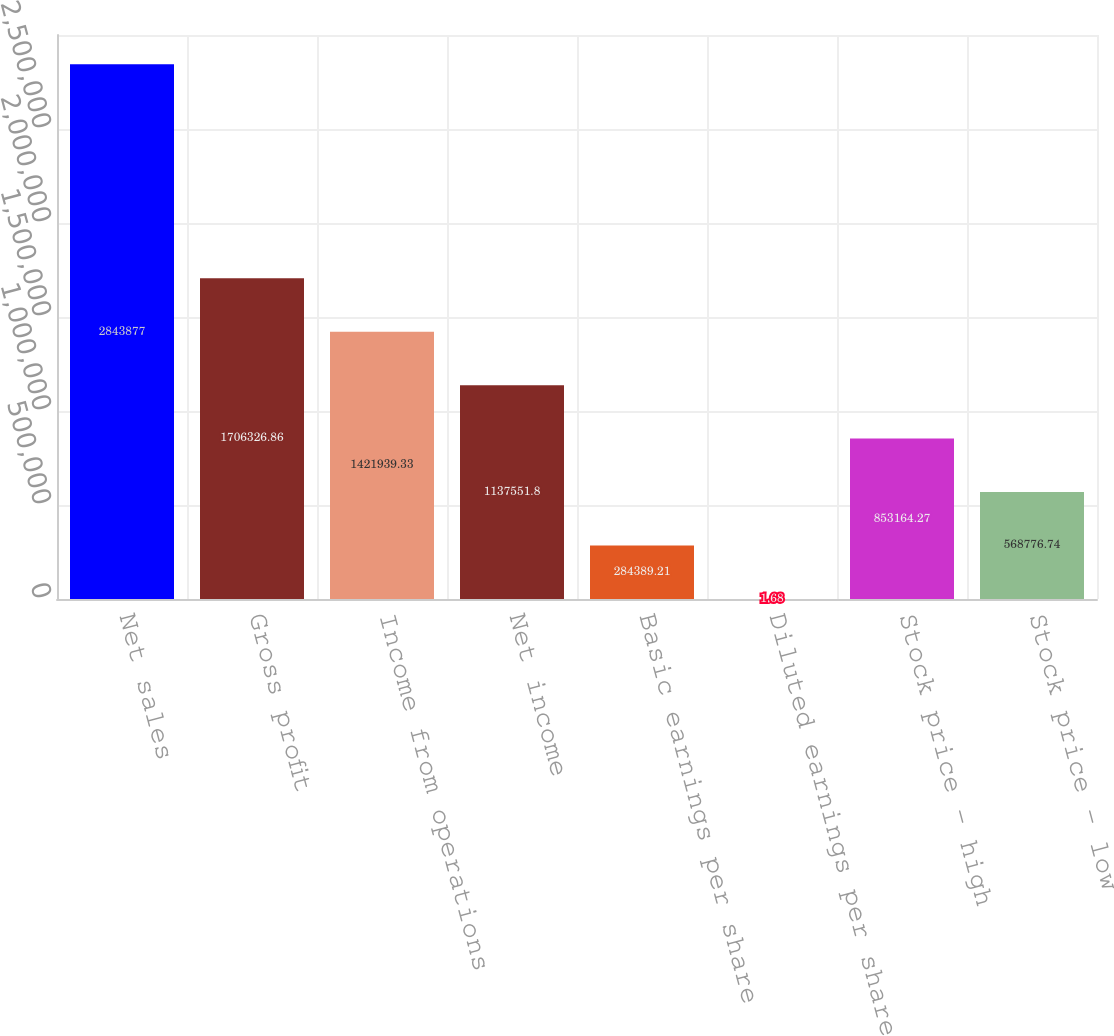Convert chart. <chart><loc_0><loc_0><loc_500><loc_500><bar_chart><fcel>Net sales<fcel>Gross profit<fcel>Income from operations<fcel>Net income<fcel>Basic earnings per share<fcel>Diluted earnings per share<fcel>Stock price - high<fcel>Stock price - low<nl><fcel>2.84388e+06<fcel>1.70633e+06<fcel>1.42194e+06<fcel>1.13755e+06<fcel>284389<fcel>1.68<fcel>853164<fcel>568777<nl></chart> 